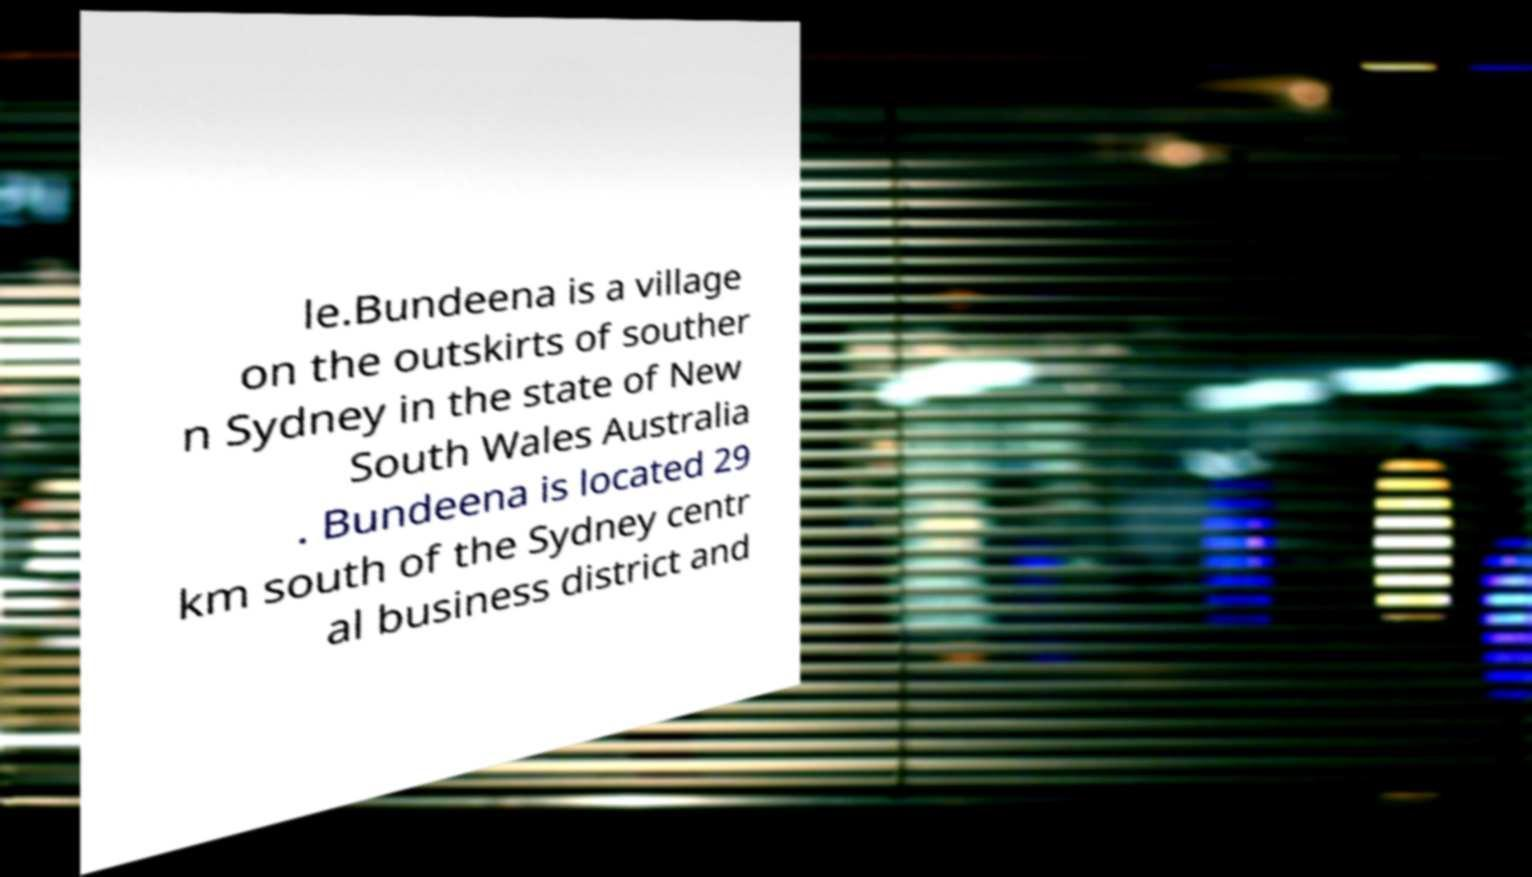Could you assist in decoding the text presented in this image and type it out clearly? le.Bundeena is a village on the outskirts of souther n Sydney in the state of New South Wales Australia . Bundeena is located 29 km south of the Sydney centr al business district and 